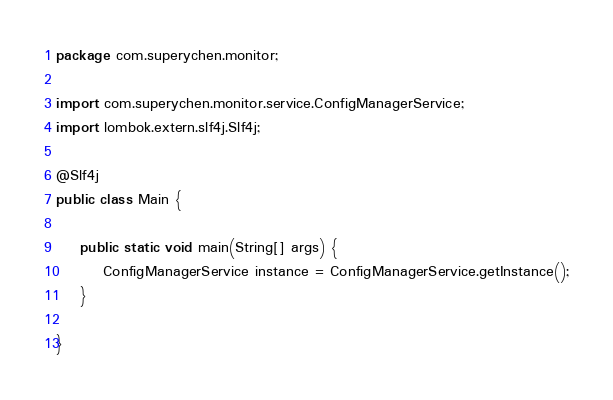<code> <loc_0><loc_0><loc_500><loc_500><_Java_>package com.superychen.monitor;

import com.superychen.monitor.service.ConfigManagerService;
import lombok.extern.slf4j.Slf4j;

@Slf4j
public class Main {

    public static void main(String[] args) {
        ConfigManagerService instance = ConfigManagerService.getInstance();
    }

}
</code> 